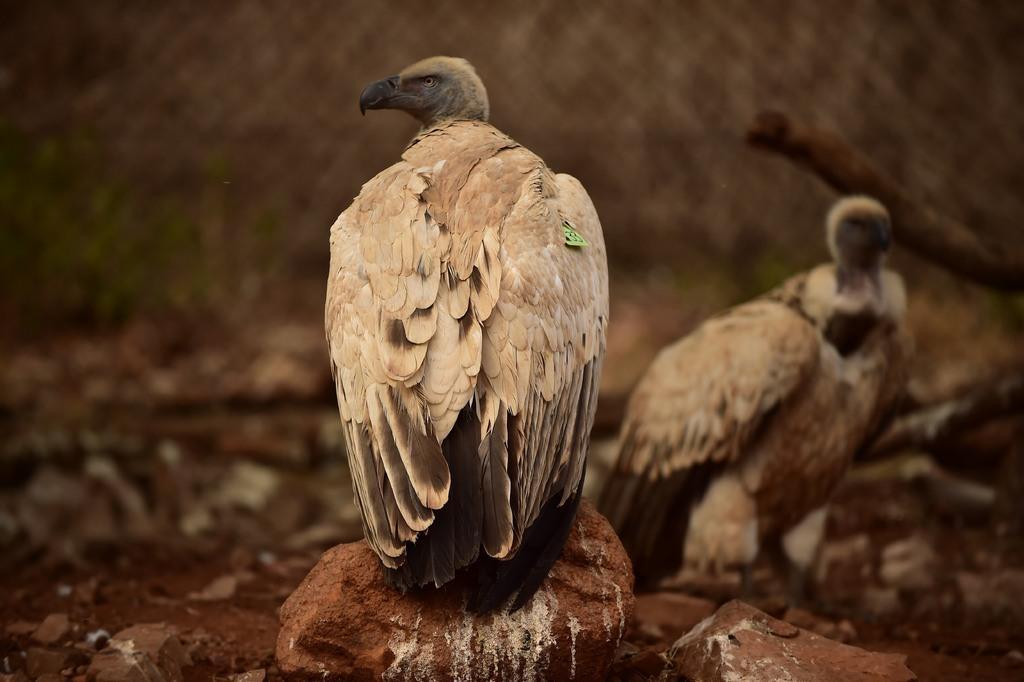Could you give a brief overview of what you see in this image? In this image we can see birds and stones. There is a blur background. 